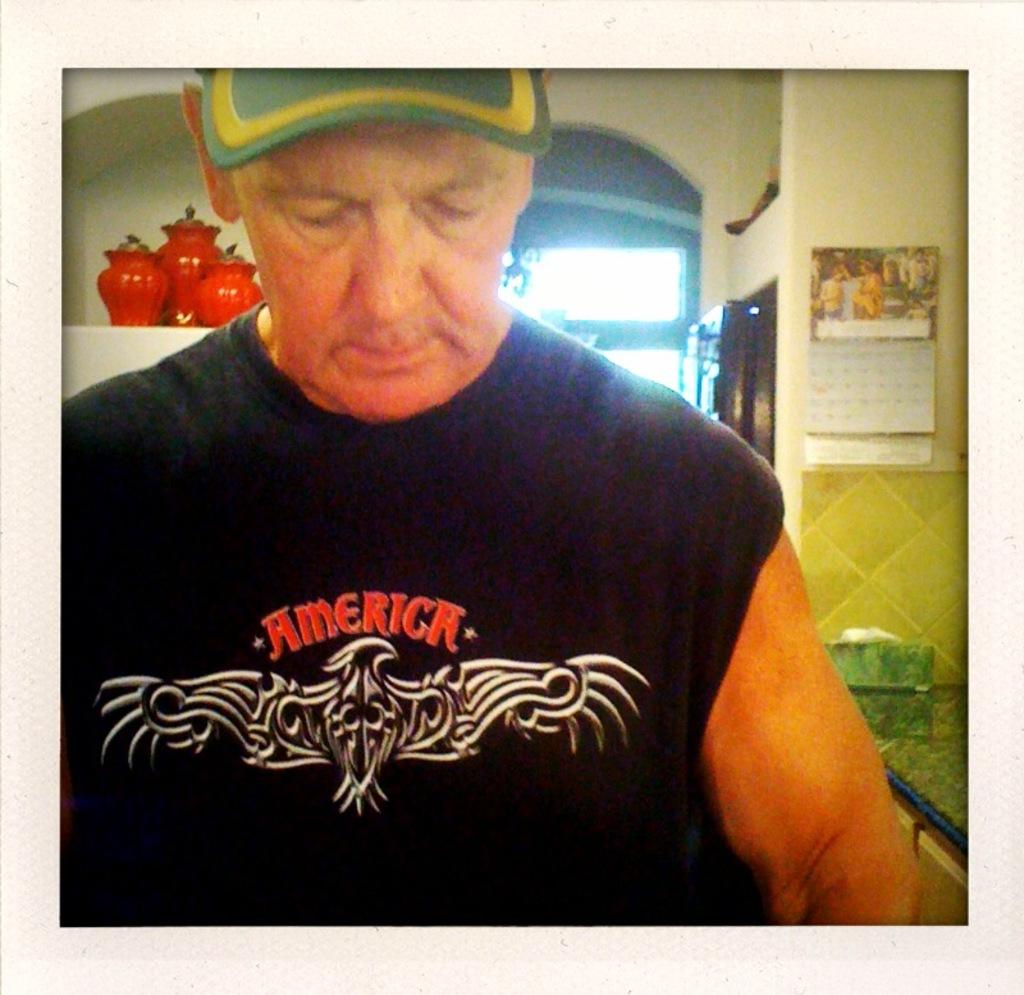Who is present in the image? There is a man in the image. What can be seen in the background of the image? There are pots, a poster, a wall, and a door in the background of the image. How many dogs are visible in the image? There are no dogs present in the image. What type of zephyr can be seen blowing through the door in the image? There is no zephyr present in the image, and the door does not show any wind blowing through it. 